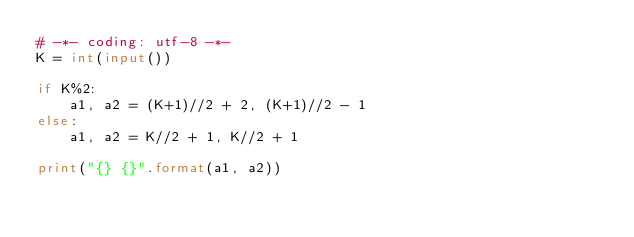Convert code to text. <code><loc_0><loc_0><loc_500><loc_500><_Python_># -*- coding: utf-8 -*-
K = int(input())

if K%2:
    a1, a2 = (K+1)//2 + 2, (K+1)//2 - 1
else:
    a1, a2 = K//2 + 1, K//2 + 1
                
print("{} {}".format(a1, a2)) </code> 